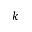<formula> <loc_0><loc_0><loc_500><loc_500>k</formula> 